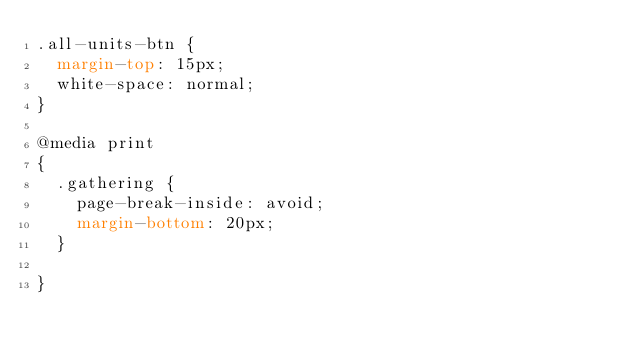<code> <loc_0><loc_0><loc_500><loc_500><_CSS_>.all-units-btn {
  margin-top: 15px;
  white-space: normal;
}

@media print
{
  .gathering {
    page-break-inside: avoid;
    margin-bottom: 20px;
  }

}
</code> 